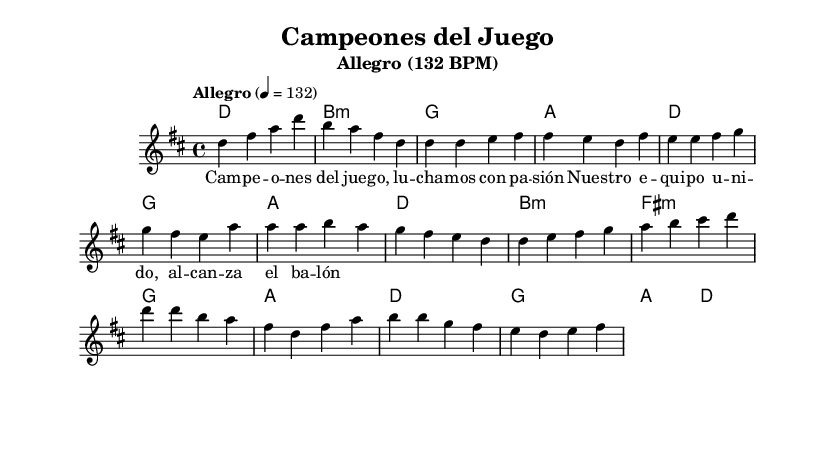What is the key signature of this music? The key signature shown at the beginning of the piece indicates that there are two sharps (F# and C#), which corresponds to D major.
Answer: D major What is the time signature of this music? The time signature is indicated as 4/4, which means there are 4 beats in each measure and the quarter note gets one beat.
Answer: 4/4 What is the tempo marking for this piece? The tempo marking is provided as "Allegro" which indicates a fast tempo of 132 beats per minute.
Answer: Allegro (132 BPM) How many measures are in the chorus section? By counting the measures in the chorus part of the score, there are four measures indicated.
Answer: 4 What chord does the piece start with? The first chord in the score, according to the harmonies, is a D major chord, which serves as the introduction's foundation.
Answer: D What is the mood conveyed by the lyrics in the verse? The lyrics suggest a theme of celebration and passion, as they express unity and the love for the game.
Answer: Celebration Describe the role of the pre-chorus in this piece. The pre-chorus acts as a bridge transitioning from the verse to the chorus, building emotional anticipation with a change in melody and harmony.
Answer: Transition/Build-up 